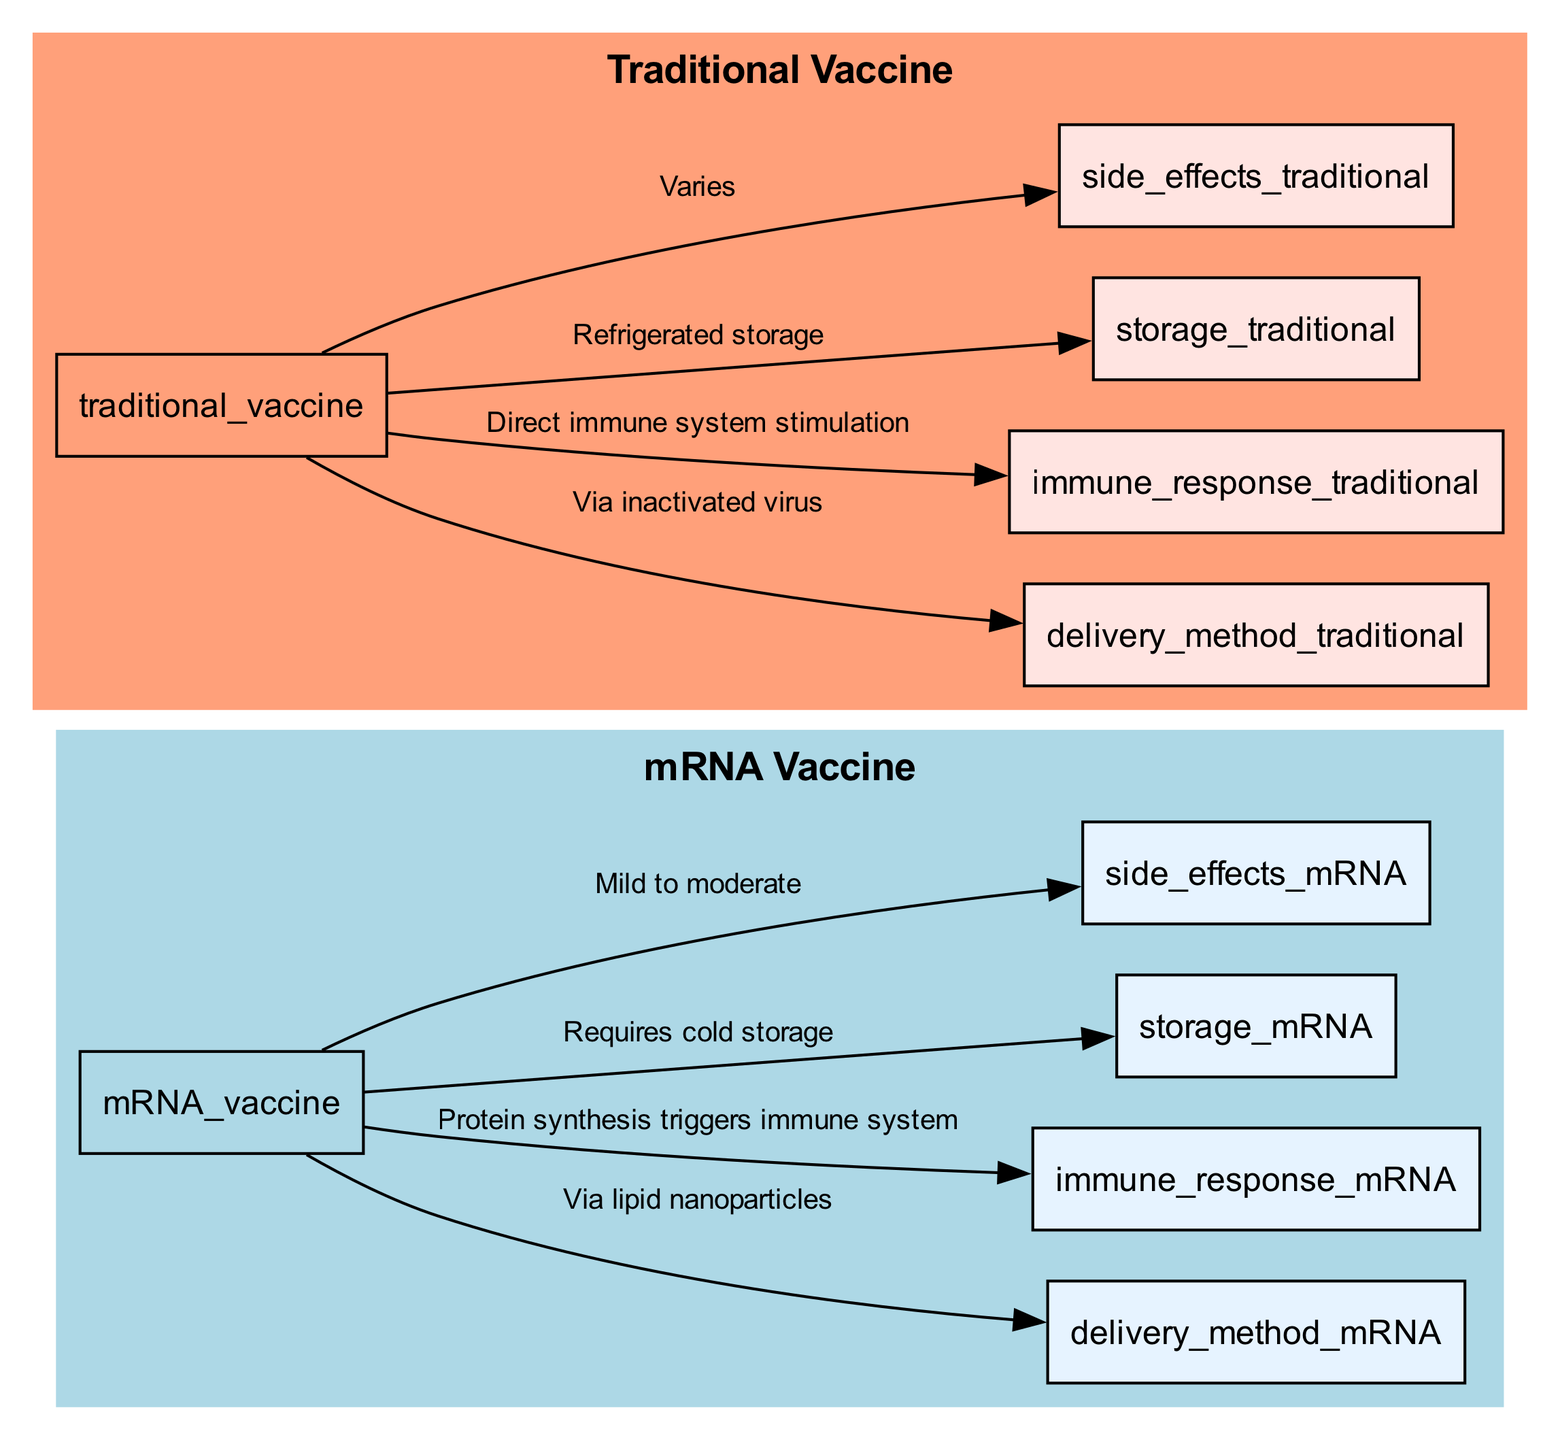What is the delivery method for mRNA vaccines? The diagram shows that mRNA vaccines use "Via lipid nanoparticles" as their delivery method. This is connected by an edge from the "mRNA Vaccine" node to the "Delivery Method" node specifically for mRNA vaccines.
Answer: Via lipid nanoparticles How do traditional vaccines stimulate the immune system? According to the diagram, traditional vaccines stimulate the immune system by "Direct immune system stimulation." This relationship is illustrated by an edge linking the "Traditional Vaccine" node to the "Immune Response" node specifically for traditional vaccines.
Answer: Direct immune system stimulation Which vaccine requires cold storage? From the diagram, it is clear that only mRNA vaccines require "Cold storage," as indicated by the edge connecting the "mRNA Vaccine" node to the "Storage" node. Traditional vaccines have a different storage requirement.
Answer: Cold storage What side effects are associated with traditional vaccines? The diagram outlines that the side effects for traditional vaccines are categorized as "Varies." This is shown through the edge that connects the "Traditional Vaccine" node to its corresponding "Side Effects" node.
Answer: Varies How many nodes represent side effects in the diagram? In the diagram, there are two nodes related to side effects, one for mRNA vaccines and one for traditional vaccines. These can be counted directly on the diagram.
Answer: 2 What is the immune response mechanism for mRNA vaccines? The diagram indicates that the immune response mechanism for mRNA vaccines is described as "Protein synthesis triggers immune system." This is shown by the directed edge from the "mRNA Vaccine" node to its respective "Immune Response" node.
Answer: Protein synthesis triggers immune system What distinguishes the storage requirements of mRNA vaccines from traditional vaccines? The storage requirements differ as mRNA vaccines need "Cold storage," while traditional vaccines only require "Refrigerated storage." This distinction can be seen by comparing the respective edges to the "Storage" nodes from each vaccine type.
Answer: Cold storage vs. Refrigerated storage Which vaccine has a more straightforward delivery method? Examining the diagram, traditional vaccines utilize "Via inactivated virus" for their delivery method, which is simpler compared to the mRNA vaccine's "Via lipid nanoparticles." This is derived from the relationships illustrated in the diagram.
Answer: Via inactivated virus 